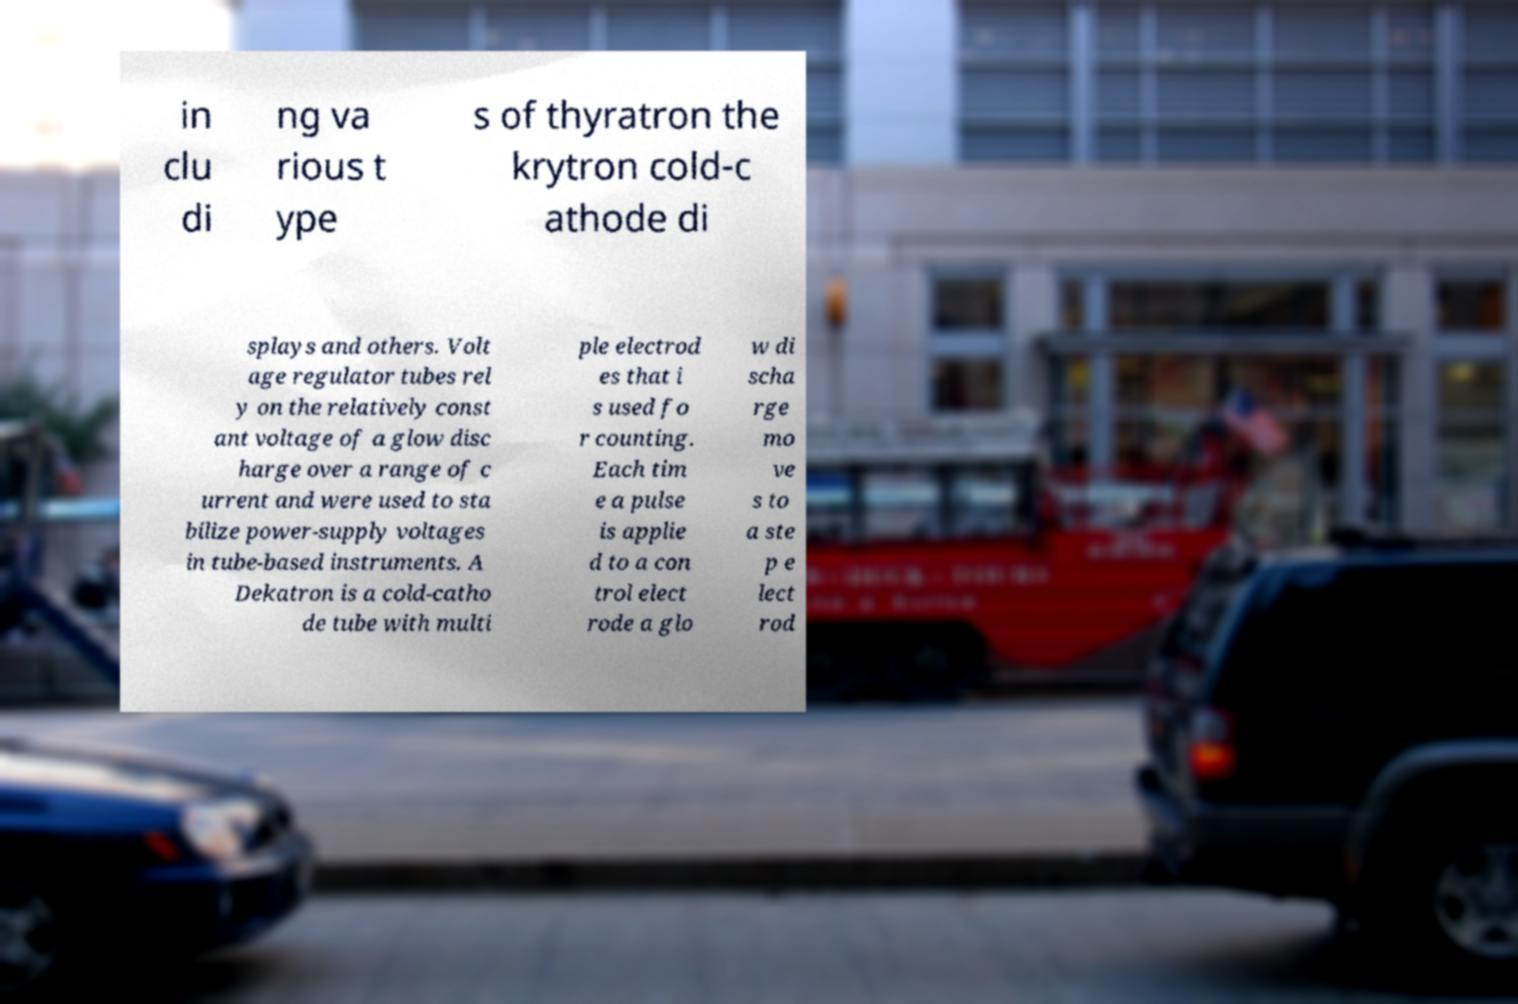Could you assist in decoding the text presented in this image and type it out clearly? in clu di ng va rious t ype s of thyratron the krytron cold-c athode di splays and others. Volt age regulator tubes rel y on the relatively const ant voltage of a glow disc harge over a range of c urrent and were used to sta bilize power-supply voltages in tube-based instruments. A Dekatron is a cold-catho de tube with multi ple electrod es that i s used fo r counting. Each tim e a pulse is applie d to a con trol elect rode a glo w di scha rge mo ve s to a ste p e lect rod 